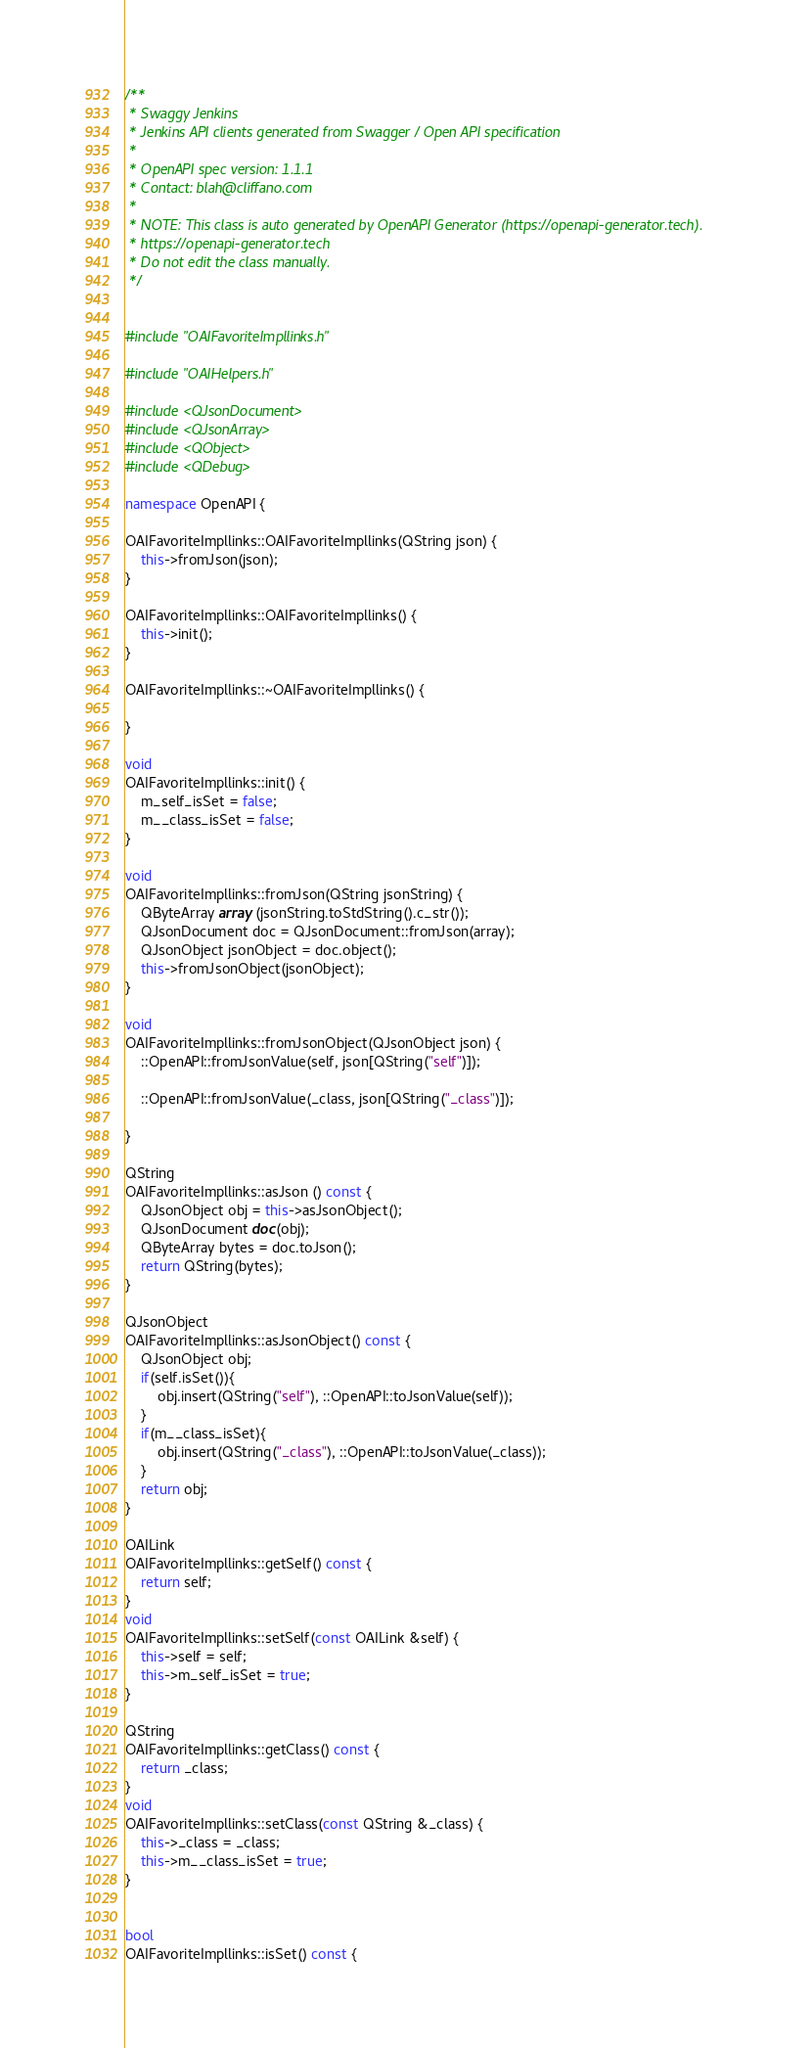Convert code to text. <code><loc_0><loc_0><loc_500><loc_500><_C++_>/**
 * Swaggy Jenkins
 * Jenkins API clients generated from Swagger / Open API specification
 *
 * OpenAPI spec version: 1.1.1
 * Contact: blah@cliffano.com
 *
 * NOTE: This class is auto generated by OpenAPI Generator (https://openapi-generator.tech).
 * https://openapi-generator.tech
 * Do not edit the class manually.
 */


#include "OAIFavoriteImpllinks.h"

#include "OAIHelpers.h"

#include <QJsonDocument>
#include <QJsonArray>
#include <QObject>
#include <QDebug>

namespace OpenAPI {

OAIFavoriteImpllinks::OAIFavoriteImpllinks(QString json) {
    this->fromJson(json);
}

OAIFavoriteImpllinks::OAIFavoriteImpllinks() {
    this->init();
}

OAIFavoriteImpllinks::~OAIFavoriteImpllinks() {
    
}

void
OAIFavoriteImpllinks::init() {
    m_self_isSet = false;
    m__class_isSet = false;
}

void
OAIFavoriteImpllinks::fromJson(QString jsonString) {
    QByteArray array (jsonString.toStdString().c_str());
    QJsonDocument doc = QJsonDocument::fromJson(array);
    QJsonObject jsonObject = doc.object();
    this->fromJsonObject(jsonObject);
}

void
OAIFavoriteImpllinks::fromJsonObject(QJsonObject json) {
    ::OpenAPI::fromJsonValue(self, json[QString("self")]);
    
    ::OpenAPI::fromJsonValue(_class, json[QString("_class")]);
    
}

QString
OAIFavoriteImpllinks::asJson () const {
    QJsonObject obj = this->asJsonObject();
    QJsonDocument doc(obj);
    QByteArray bytes = doc.toJson();
    return QString(bytes);
}

QJsonObject
OAIFavoriteImpllinks::asJsonObject() const {
    QJsonObject obj;
	if(self.isSet()){
        obj.insert(QString("self"), ::OpenAPI::toJsonValue(self));
    }
	if(m__class_isSet){
        obj.insert(QString("_class"), ::OpenAPI::toJsonValue(_class));
    }
    return obj;
}

OAILink
OAIFavoriteImpllinks::getSelf() const {
    return self;
}
void
OAIFavoriteImpllinks::setSelf(const OAILink &self) {
    this->self = self;
    this->m_self_isSet = true;
}

QString
OAIFavoriteImpllinks::getClass() const {
    return _class;
}
void
OAIFavoriteImpllinks::setClass(const QString &_class) {
    this->_class = _class;
    this->m__class_isSet = true;
}


bool
OAIFavoriteImpllinks::isSet() const {</code> 